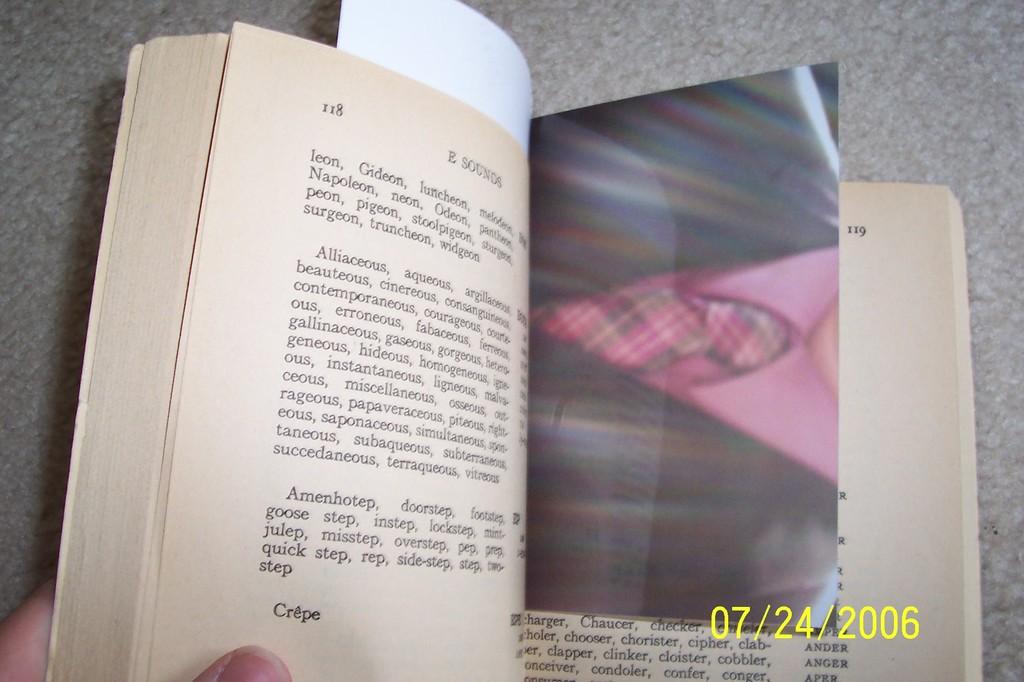What date was the picture taken?
Your answer should be compact. 07/24/2006. 